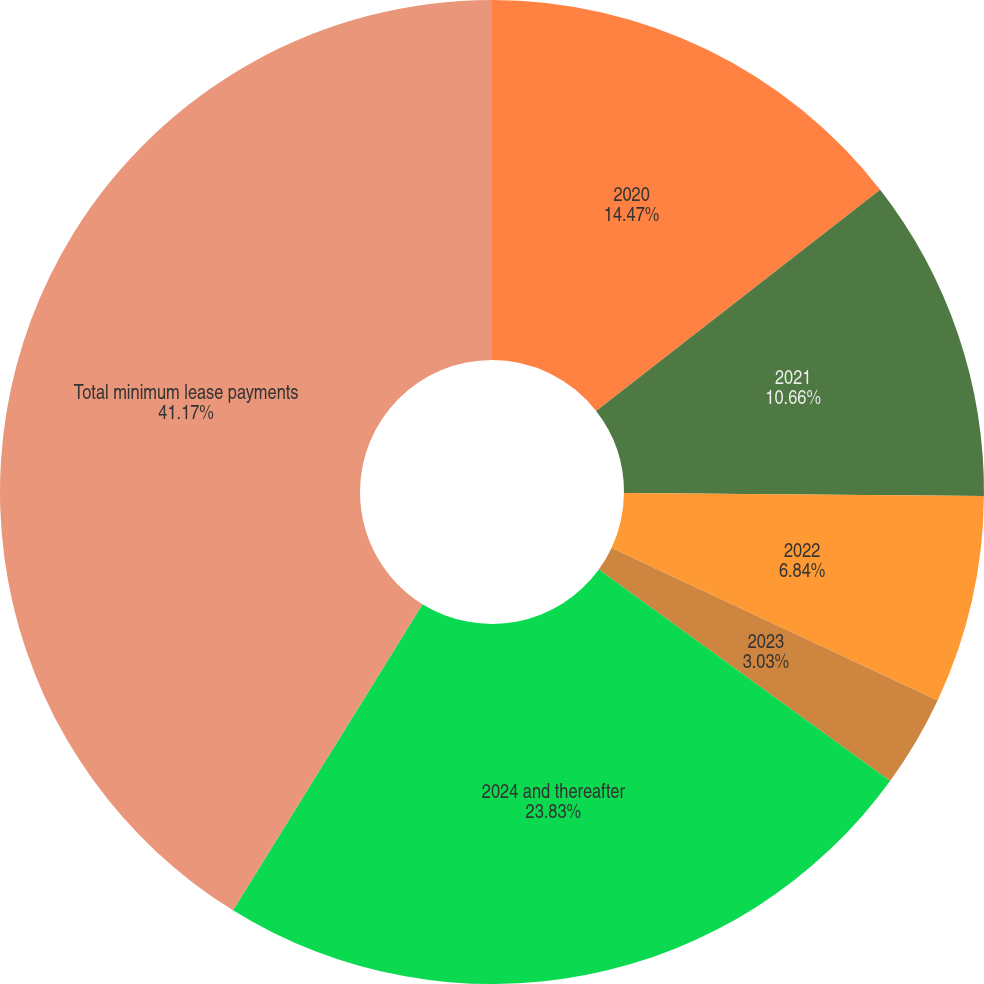Convert chart to OTSL. <chart><loc_0><loc_0><loc_500><loc_500><pie_chart><fcel>2020<fcel>2021<fcel>2022<fcel>2023<fcel>2024 and thereafter<fcel>Total minimum lease payments<nl><fcel>14.47%<fcel>10.66%<fcel>6.84%<fcel>3.03%<fcel>23.83%<fcel>41.18%<nl></chart> 